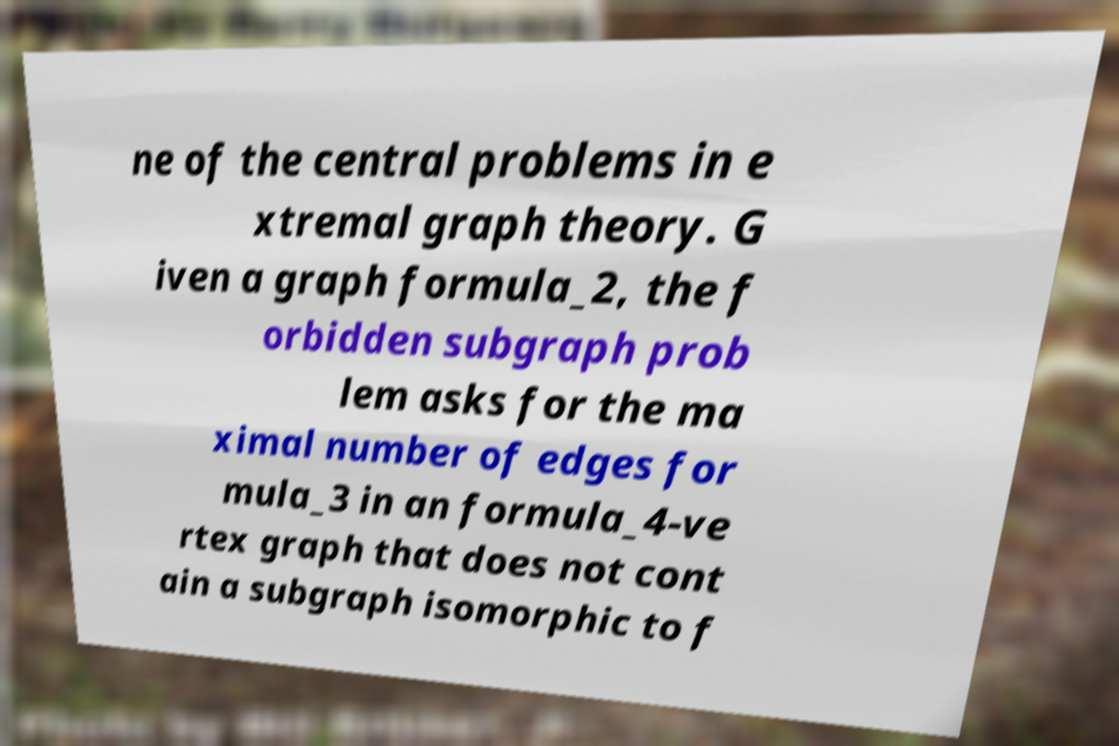I need the written content from this picture converted into text. Can you do that? ne of the central problems in e xtremal graph theory. G iven a graph formula_2, the f orbidden subgraph prob lem asks for the ma ximal number of edges for mula_3 in an formula_4-ve rtex graph that does not cont ain a subgraph isomorphic to f 